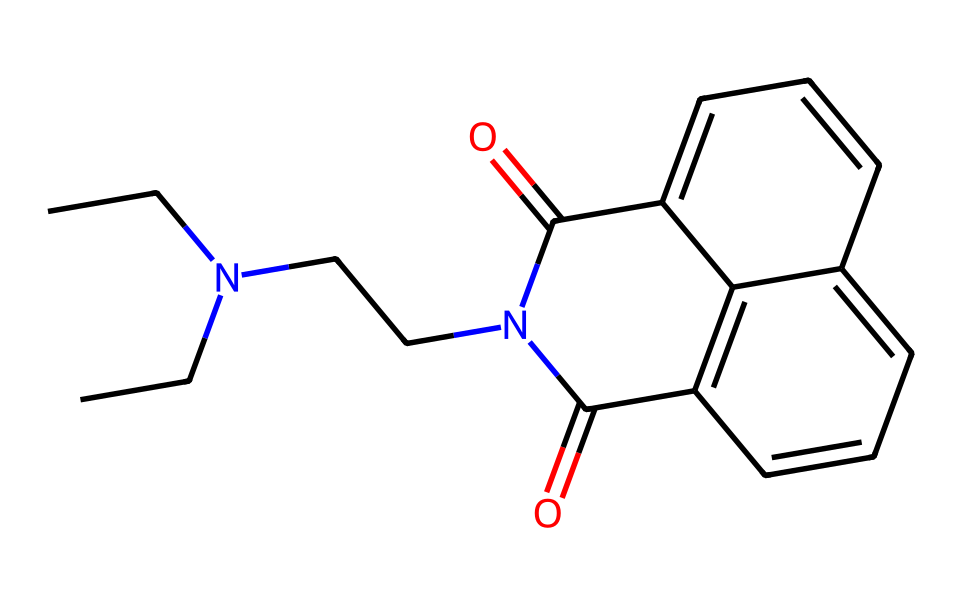What is the main functional group present in this chemical? The structure contains a carbonyl group (C=O) and an amide linkage (C=O-N), which characterizes it as an imide.
Answer: imide How many carbon atoms are present in this structure? By counting the carbon atoms in the chemical structure, we see there are 13 carbon atoms in total.
Answer: 13 What type of bonding is primarily present in this compound? The compound presents a mix of single, double, and polar covalent bonds, mainly through its carbonyl and aromatic components.
Answer: covalent Does this chemical have any nitrogen atoms? A visual inspection of the SMILES reveals the presence of two nitrogen atoms in the side chain of the imide.
Answer: yes What could be the role of this molecule in building materials? As a flame retardant, this chemical likely serves to inhibit the combustion process in materials.
Answer: flame retardant How many rings are present in the molecular structure? Upon analyzing the structure, it is evident that there are three interconnected rings within the chemical, forming part of its aromatic nature.
Answer: 3 What is the general classification of this chemical based on its structure? The presence of the imide functional group and aromatic rings indicates that this chemical is classified as an aromatic imide.
Answer: aromatic imide 